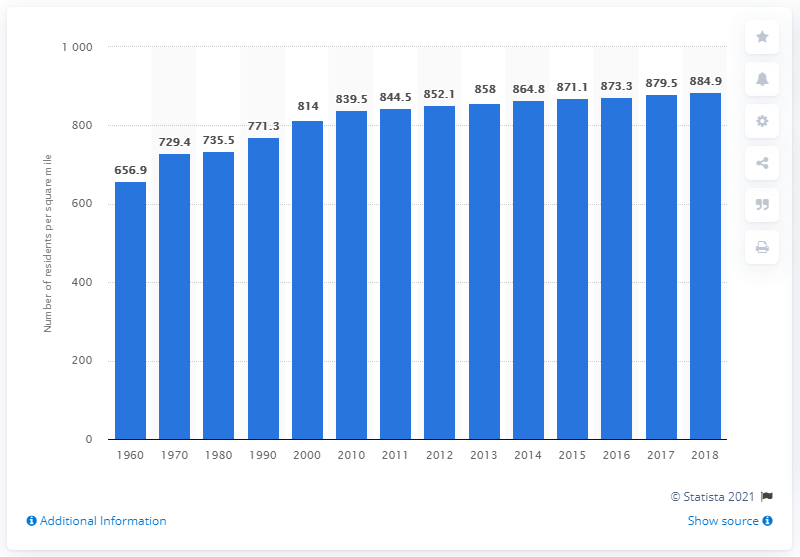Point out several critical features in this image. In 2018, the population density of Massachusetts was estimated to be 884.9 people per square mile. 